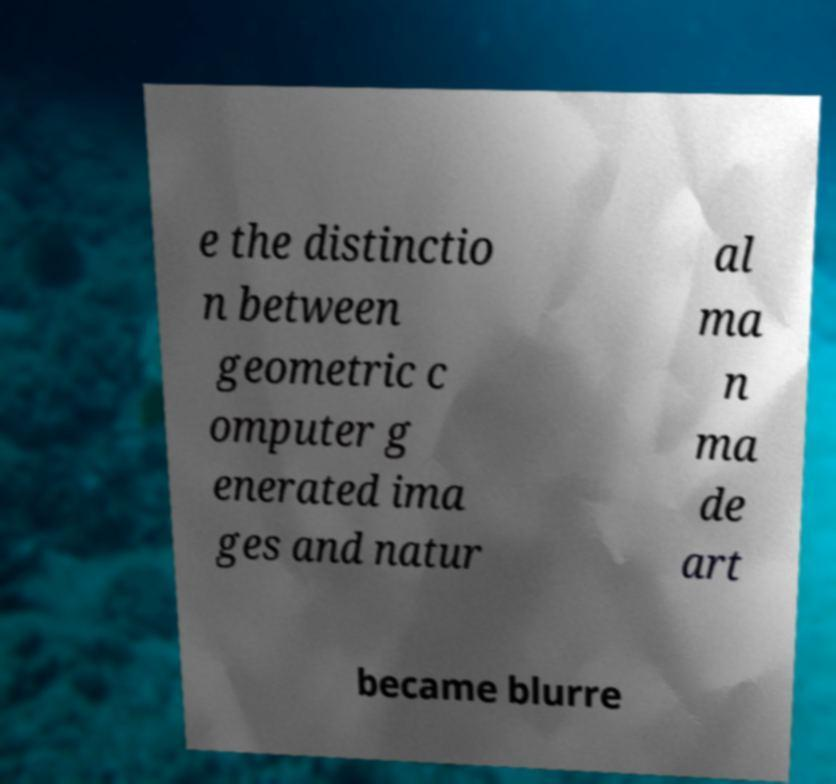There's text embedded in this image that I need extracted. Can you transcribe it verbatim? e the distinctio n between geometric c omputer g enerated ima ges and natur al ma n ma de art became blurre 